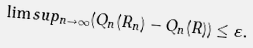Convert formula to latex. <formula><loc_0><loc_0><loc_500><loc_500>\lim s u p _ { n \to \infty } ( Q _ { n } ( R _ { n } ) - Q _ { n } ( R ) ) \leq \varepsilon .</formula> 